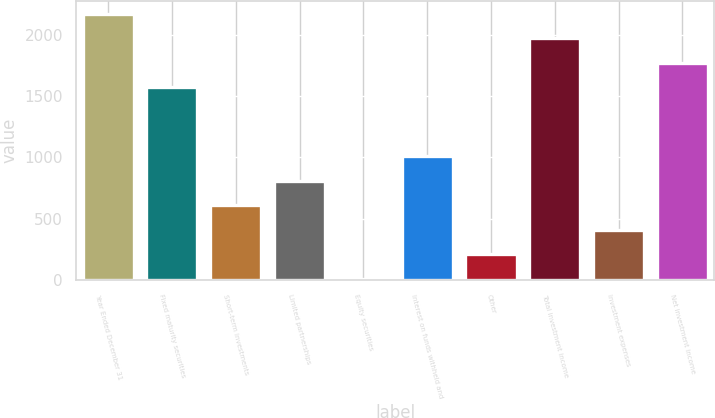<chart> <loc_0><loc_0><loc_500><loc_500><bar_chart><fcel>Year Ended December 31<fcel>Fixed maturity securities<fcel>Short-term investments<fcel>Limited partnerships<fcel>Equity securities<fcel>Interest on funds withheld and<fcel>Other<fcel>Total investment income<fcel>Investment expenses<fcel>Net investment income<nl><fcel>2168.26<fcel>1571.2<fcel>610.86<fcel>809.88<fcel>13.8<fcel>1008.9<fcel>212.82<fcel>1969.24<fcel>411.84<fcel>1770.22<nl></chart> 